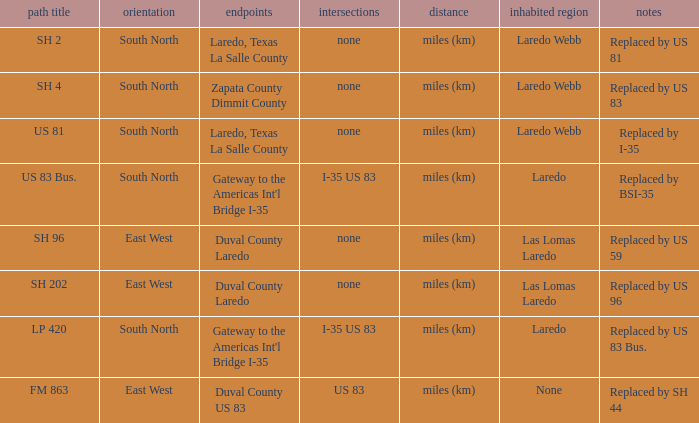How many termini are there that have "east west" listed in their direction section, "none" listed in their junction section, and have a route name of "sh 202"? 1.0. 